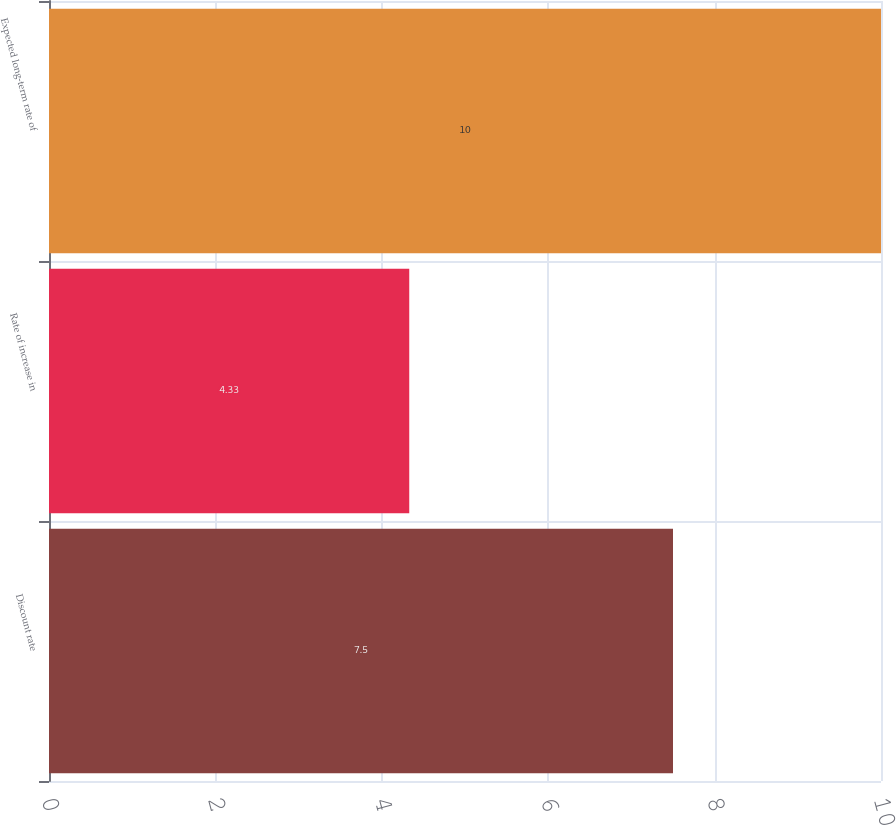<chart> <loc_0><loc_0><loc_500><loc_500><bar_chart><fcel>Discount rate<fcel>Rate of increase in<fcel>Expected long-term rate of<nl><fcel>7.5<fcel>4.33<fcel>10<nl></chart> 